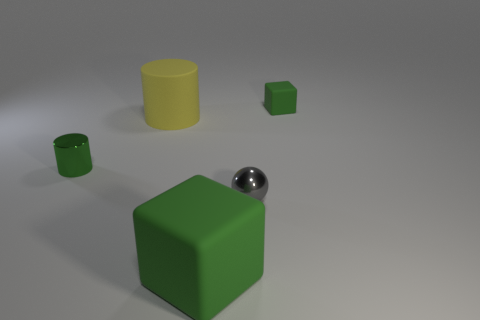Add 1 tiny purple rubber balls. How many objects exist? 6 Subtract all cubes. How many objects are left? 3 Add 2 matte cylinders. How many matte cylinders exist? 3 Subtract 0 yellow blocks. How many objects are left? 5 Subtract all big green things. Subtract all large green rubber spheres. How many objects are left? 4 Add 2 large green matte blocks. How many large green matte blocks are left? 3 